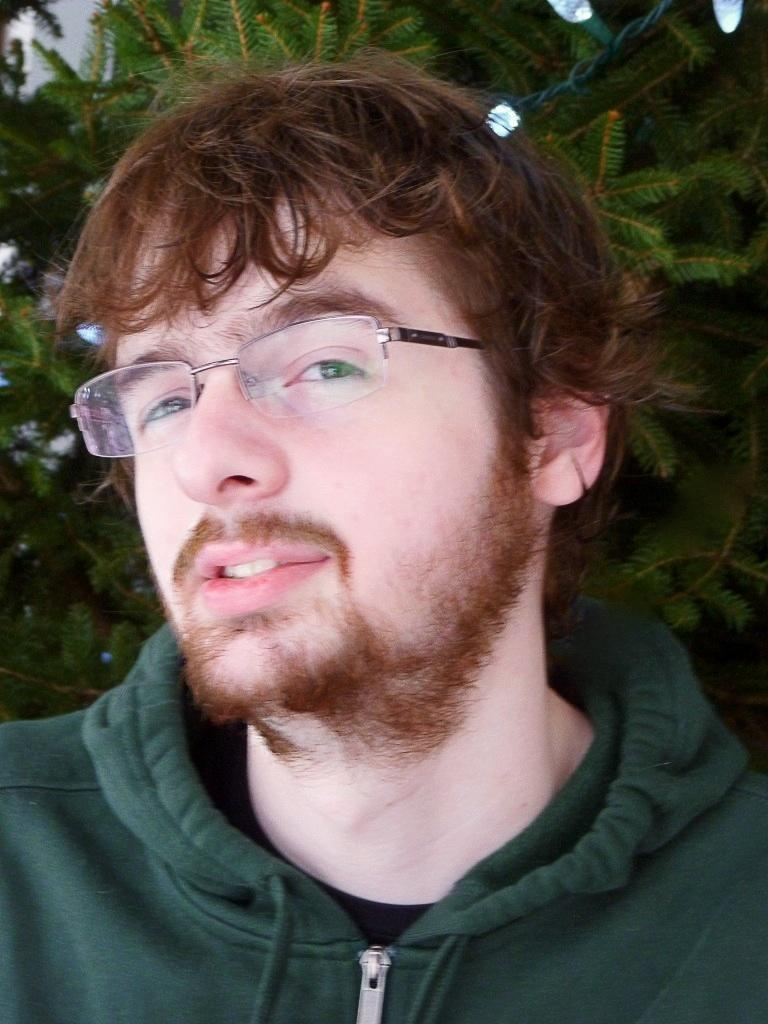Who is present in the image? There is a man in the image. What is the man wearing? The man is wearing a green sweater. What can be seen in the background of the image? There is a tree in the background of the image. What type of wrench is the man holding in the image? There is no wrench present in the image; the man is not holding any tools. 